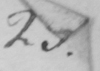Please provide the text content of this handwritten line. 23. 